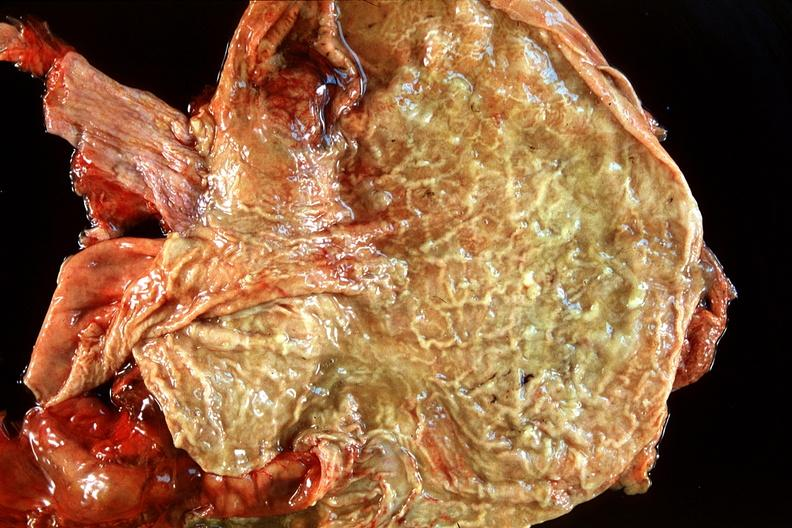s this present?
Answer the question using a single word or phrase. No 